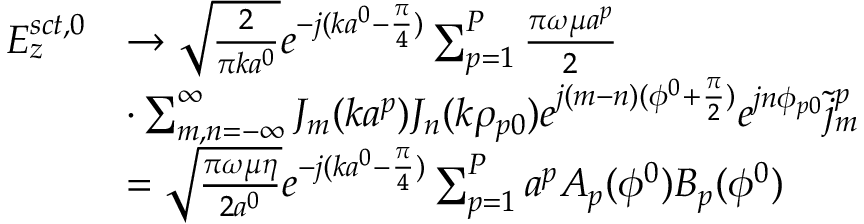<formula> <loc_0><loc_0><loc_500><loc_500>\begin{array} { r l } { E _ { z } ^ { s c t , 0 } } & { \rightarrow \sqrt { \frac { 2 } { \pi k a ^ { 0 } } } e ^ { - j ( k a ^ { 0 } - { \frac { \pi } { 4 } } ) } \sum _ { p = 1 } ^ { P } { \frac { \pi \omega \mu a ^ { p } } { 2 } } } \\ & { \cdot \sum _ { m , n = - \infty } ^ { \infty } J _ { m } ( k a ^ { p } ) J _ { n } ( k \rho _ { p 0 } ) e ^ { j ( m - n ) ( \phi ^ { 0 } + { \frac { \pi } { 2 } } ) } e ^ { j n \phi _ { p 0 } } \tilde { j } _ { m } ^ { p } } \\ & { = \sqrt { \frac { \pi \omega \mu \eta } { 2 a ^ { 0 } } } e ^ { - j ( k a ^ { 0 } - { \frac { \pi } { 4 } } ) } \sum _ { p = 1 } ^ { P } a ^ { p } A _ { p } ( \phi ^ { 0 } ) B _ { p } ( \phi ^ { 0 } ) } \end{array}</formula> 